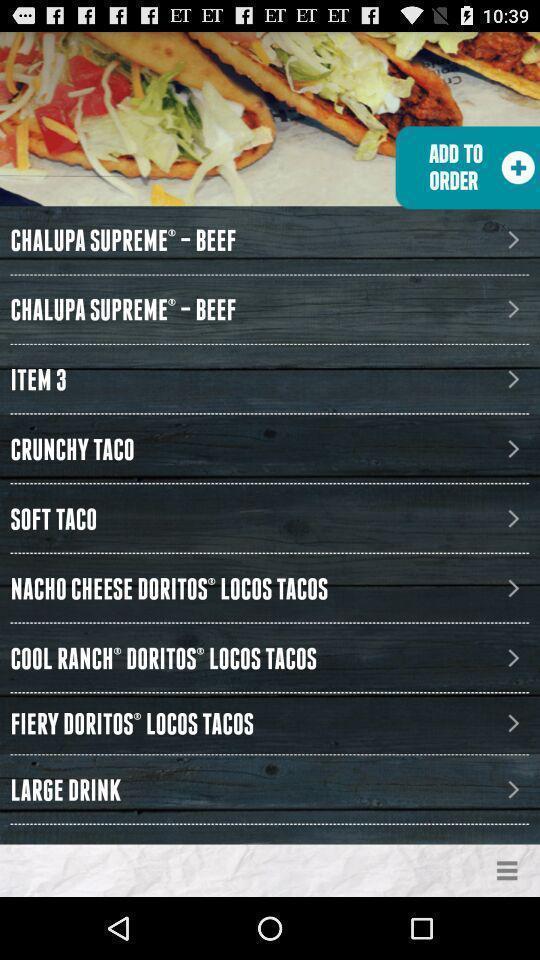Describe the key features of this screenshot. Screen shows menu from a online food store. 